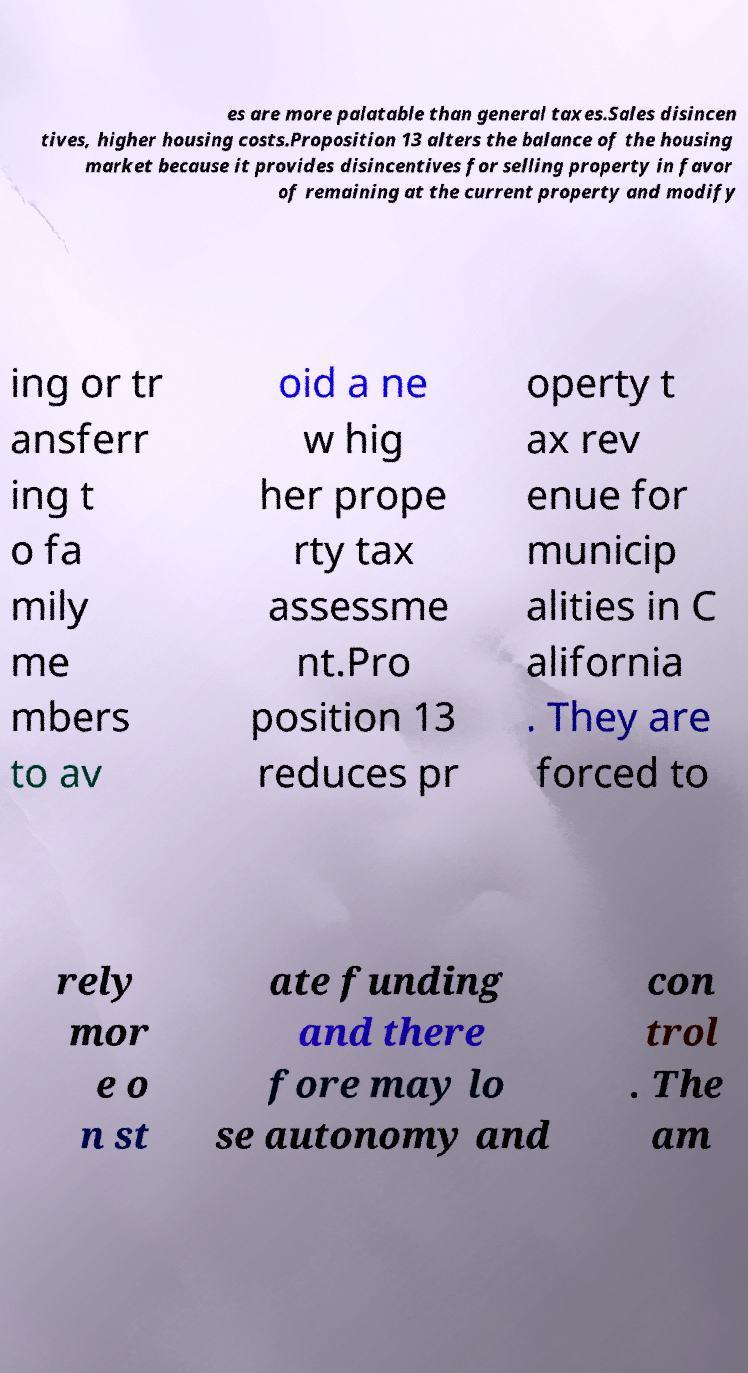Could you extract and type out the text from this image? es are more palatable than general taxes.Sales disincen tives, higher housing costs.Proposition 13 alters the balance of the housing market because it provides disincentives for selling property in favor of remaining at the current property and modify ing or tr ansferr ing t o fa mily me mbers to av oid a ne w hig her prope rty tax assessme nt.Pro position 13 reduces pr operty t ax rev enue for municip alities in C alifornia . They are forced to rely mor e o n st ate funding and there fore may lo se autonomy and con trol . The am 